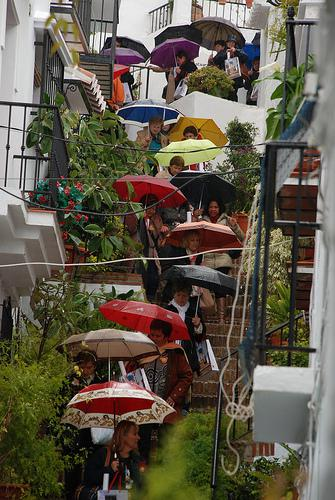Question: how many umbrellas are there?
Choices:
A. Twenty.
B. Fifteen.
C. Eight.
D. Six.
Answer with the letter. Answer: B Question: how many red umbrellas are there?
Choices:
A. Four.
B. Six.
C. Eight.
D. Two.
Answer with the letter. Answer: D Question: what color are the walls?
Choices:
A. Yellow.
B. Red.
C. White.
D. Blue.
Answer with the letter. Answer: C Question: how many purple umbrellas are in the picture?
Choices:
A. One.
B. Four.
C. Two.
D. Zero.
Answer with the letter. Answer: C Question: how many of the umbrellas are blue?
Choices:
A. Six.
B. Eight.
C. One.
D. Two.
Answer with the letter. Answer: C 